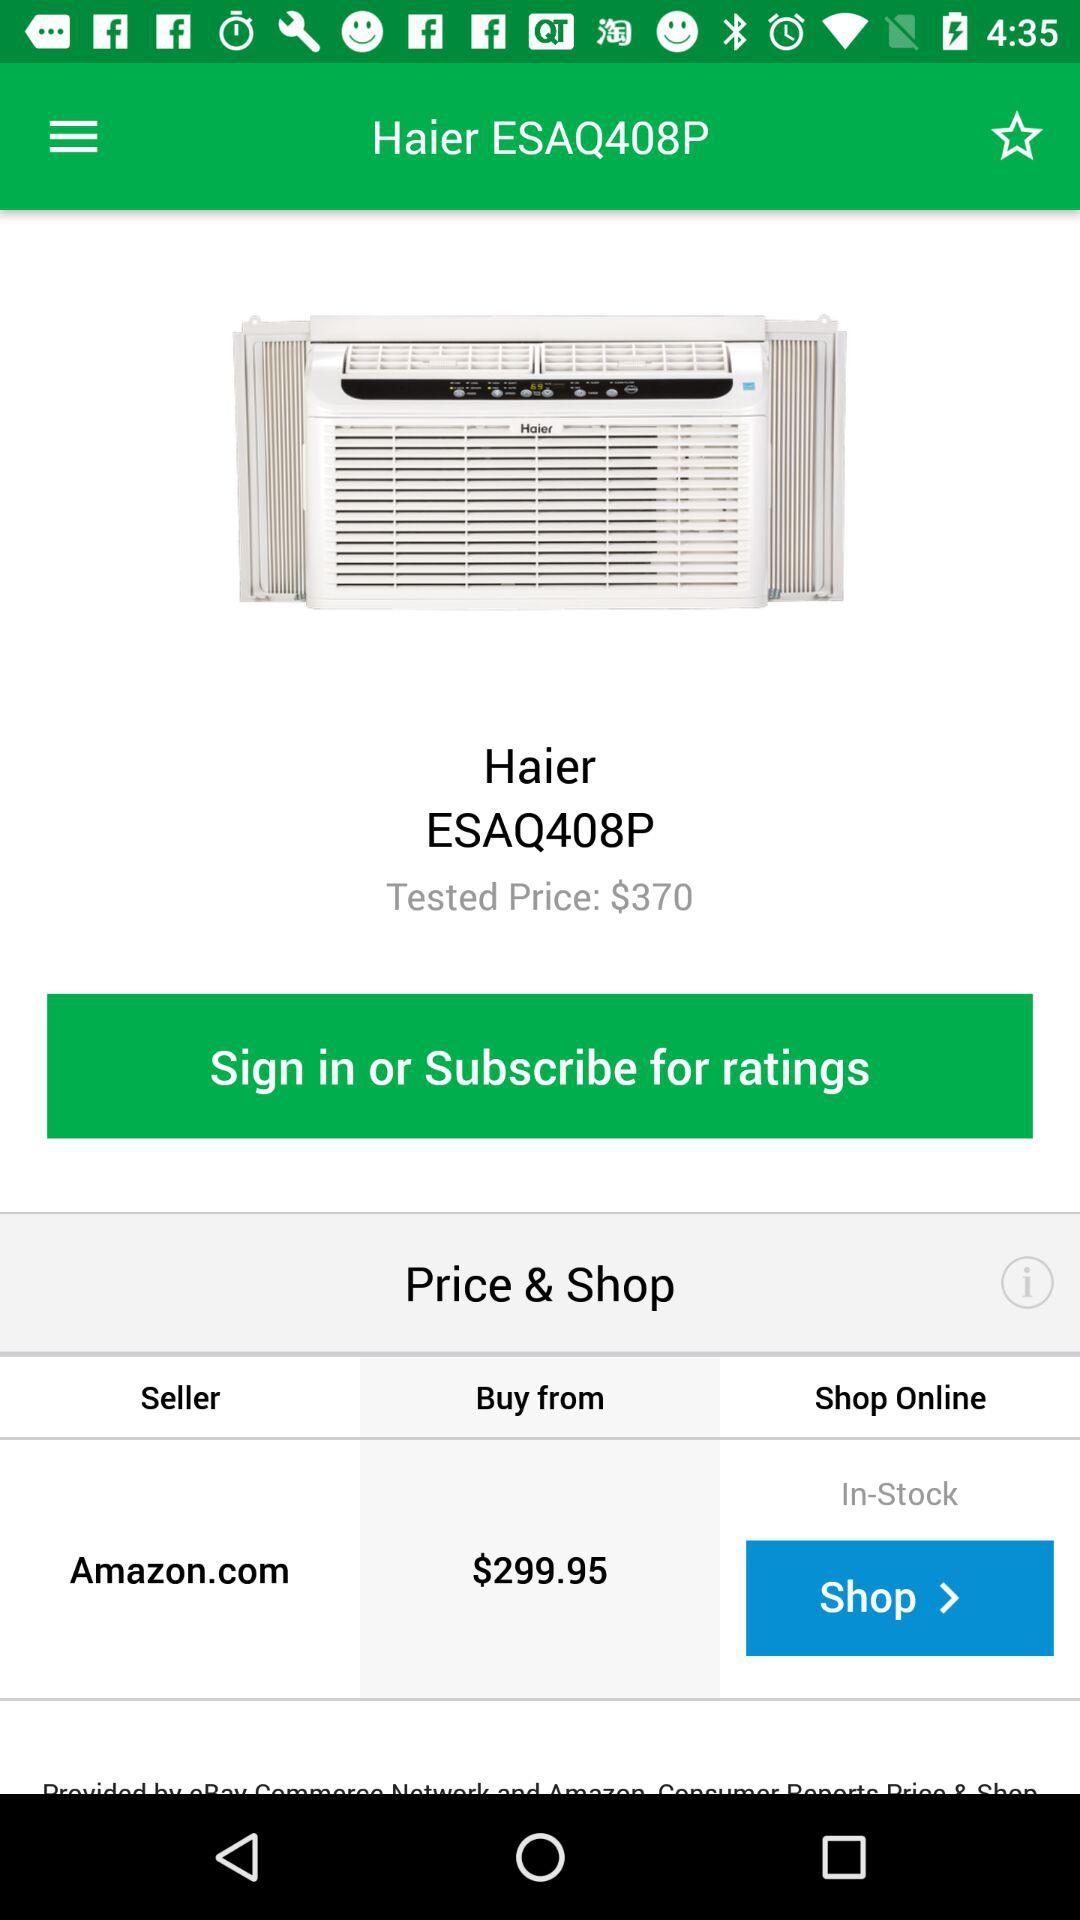What is the buying price? The price starts at $299.95. 